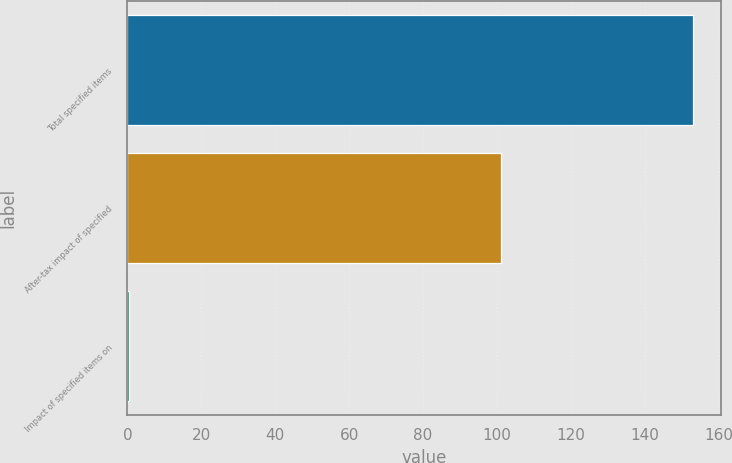Convert chart to OTSL. <chart><loc_0><loc_0><loc_500><loc_500><bar_chart><fcel>Total specified items<fcel>After-tax impact of specified<fcel>Impact of specified items on<nl><fcel>153<fcel>101<fcel>0.51<nl></chart> 